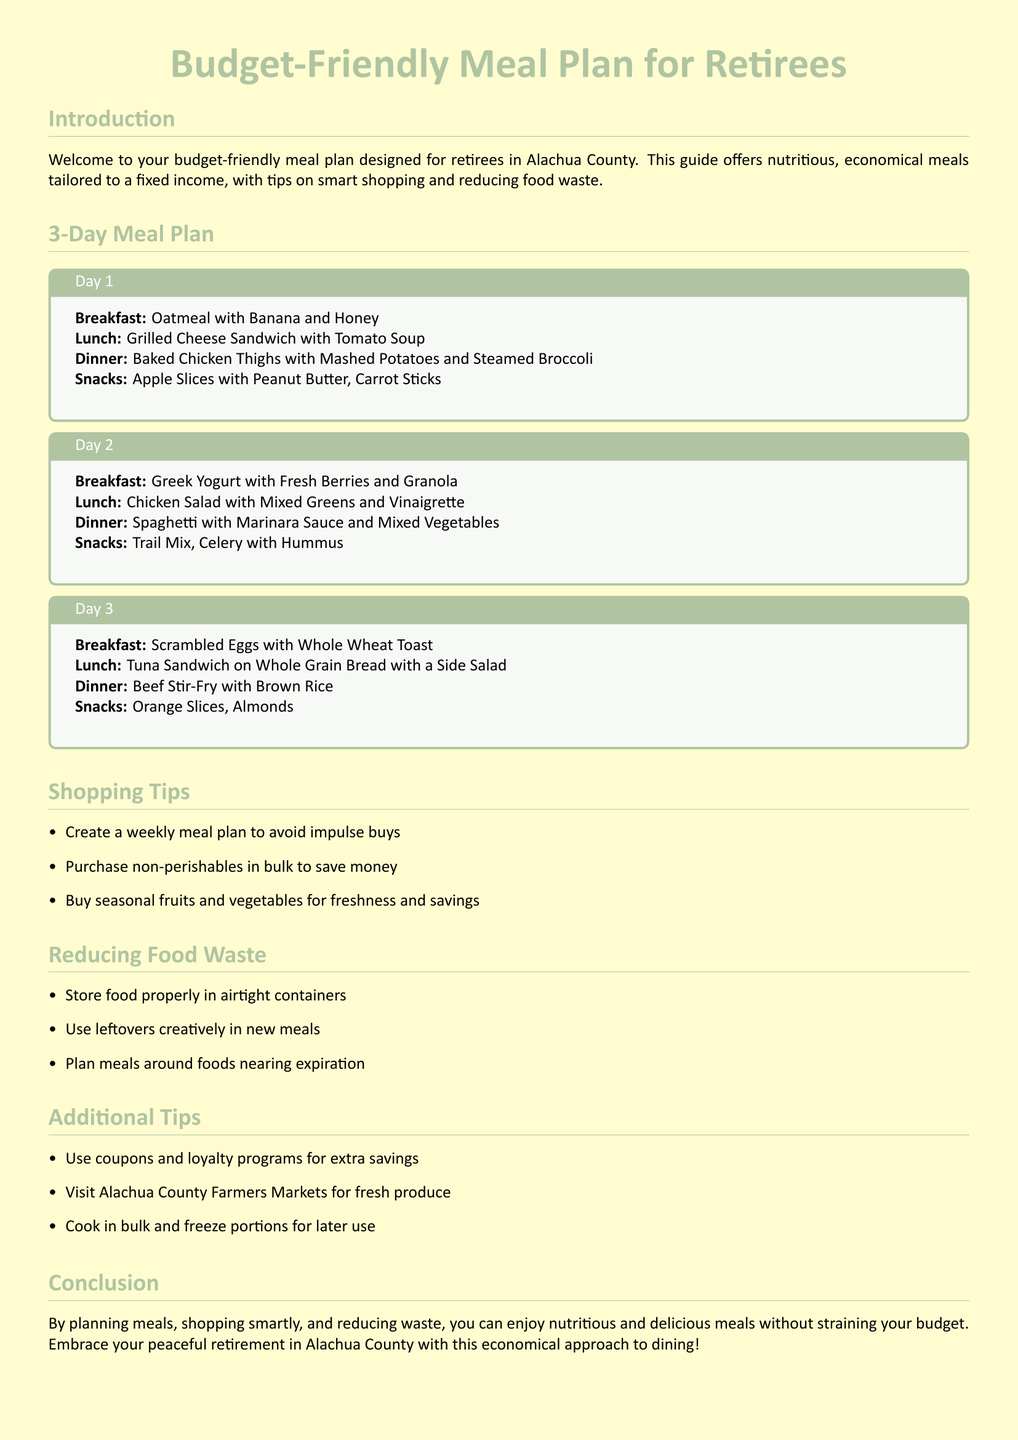what is the title of the document? The title of the document is prominently displayed at the top.
Answer: Budget-Friendly Meal Plan for Retirees how many days does the meal plan cover? The document lists meals for three distinct days.
Answer: 3 what is breakfast for Day 2? The specific meal is listed under Day 2 in the meal plan section.
Answer: Greek Yogurt with Fresh Berries and Granola what snack is suggested for Day 1? The snacks available on Day 1 are mentioned in the meal plan.
Answer: Apple Slices with Peanut Butter, Carrot Sticks what is one shopping tip provided? The document lists several tips under the shopping section.
Answer: Create a weekly meal plan to avoid impulse buys how should food be stored to reduce waste? Suggestions for food storage are provided in the reducing waste section.
Answer: In airtight containers what is the main protein source for Dinner on Day 3? The protein source for the specific meal is detailed in the meal plan.
Answer: Beef Stir-Fry where can retirees find fresh produce in Alachua County? One suggestion for sourcing fresh produce is mentioned under additional tips.
Answer: Alachua County Farmers Markets what meal features chicken on Day 1? The meal is explicitly outlined under Day 1 in the document.
Answer: Baked Chicken Thighs with Mashed Potatoes and Steamed Broccoli 